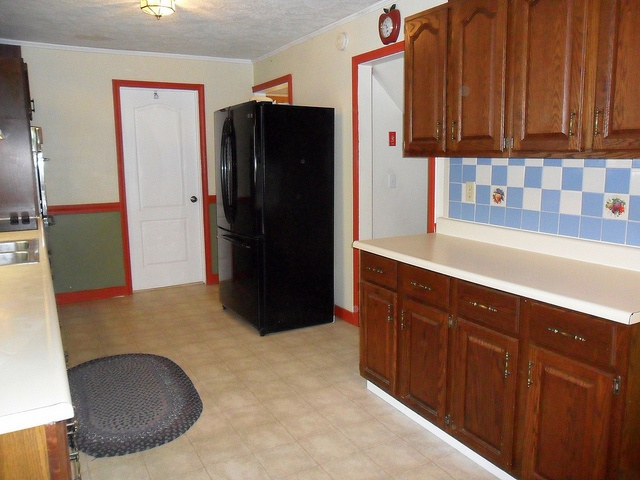Describe the objects in this image and their specific colors. I can see refrigerator in gray and black tones, oven in gray, darkgray, lightgray, and black tones, sink in gray, lightgray, and darkgray tones, and clock in gray, darkgray, and maroon tones in this image. 